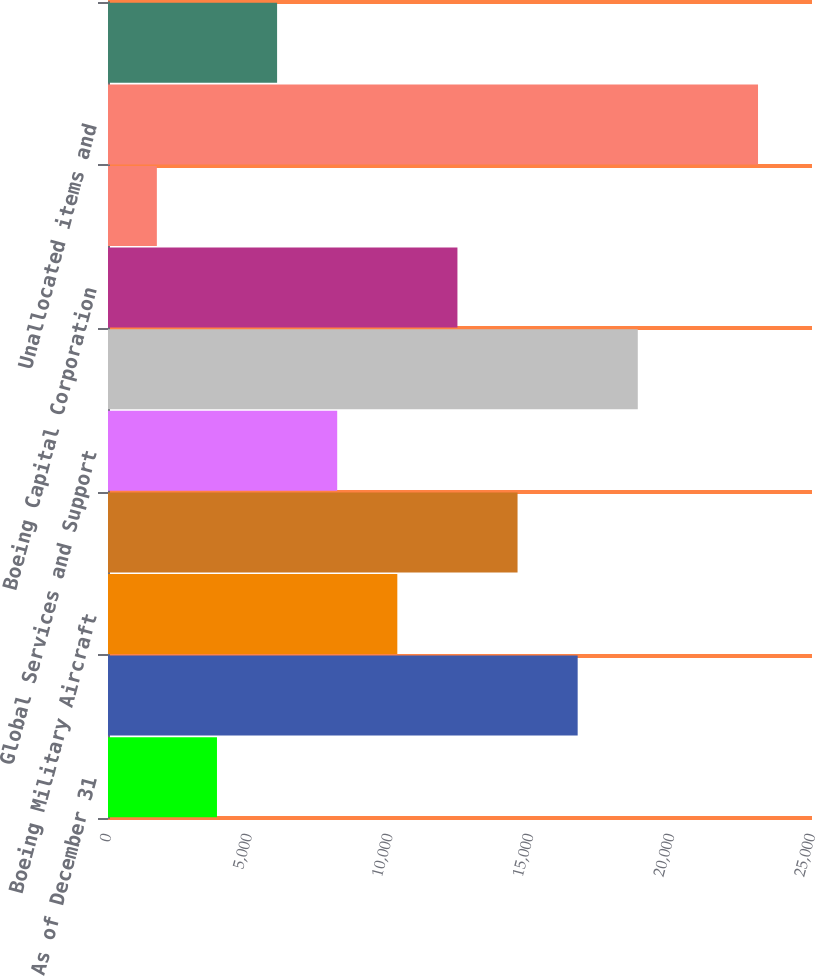<chart> <loc_0><loc_0><loc_500><loc_500><bar_chart><fcel>As of December 31<fcel>Commercial Airplanes<fcel>Boeing Military Aircraft<fcel>Network and Space Systems<fcel>Global Services and Support<fcel>Total Integrated Defense<fcel>Boeing Capital Corporation<fcel>Other<fcel>Unallocated items and<fcel>Years ended December 31<nl><fcel>3869.8<fcel>16678.6<fcel>10274.2<fcel>14543.8<fcel>8139.4<fcel>18813.4<fcel>12409<fcel>1735<fcel>23083<fcel>6004.6<nl></chart> 